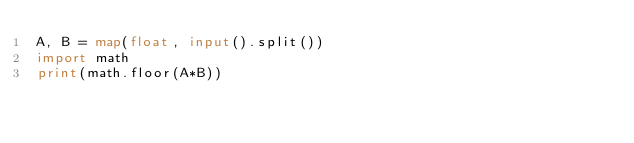Convert code to text. <code><loc_0><loc_0><loc_500><loc_500><_Python_>A, B = map(float, input().split())
import math
print(math.floor(A*B))</code> 